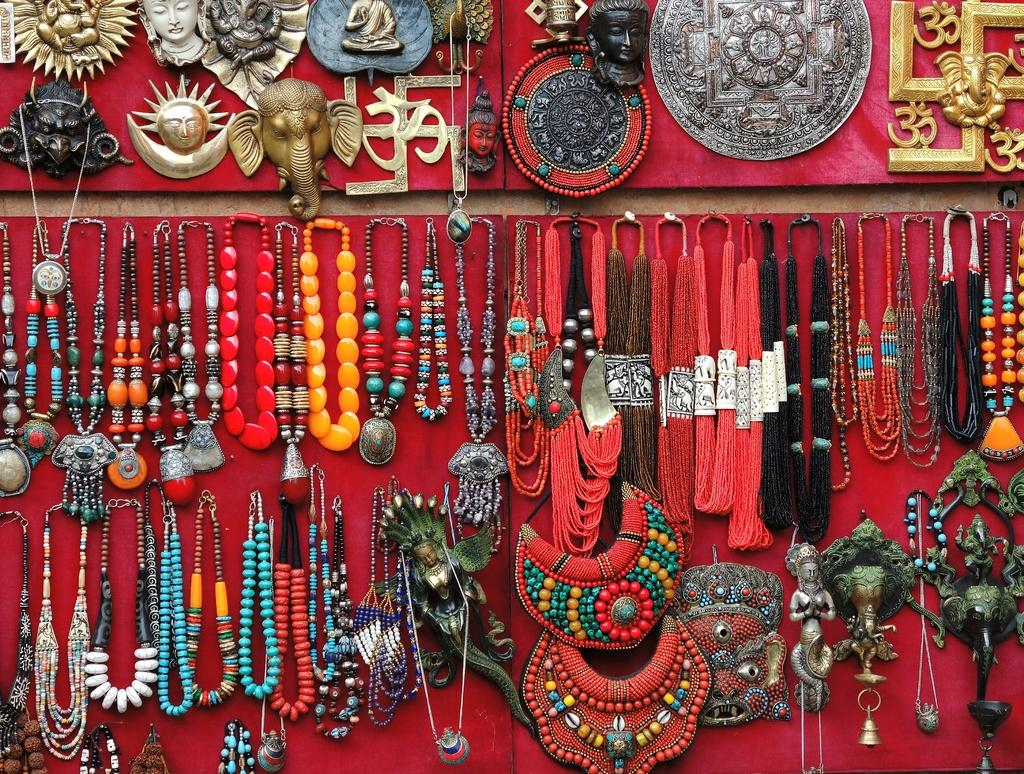What type of items are featured in the image? There are many neck pieces and antique pieces in the image. Can you describe the color of the cloth on the board? The cloth on the board is red. How many antiques can be seen in the image? There are many antiques in the image. What type of balloon is present in the image? There is no balloon present in the image. 